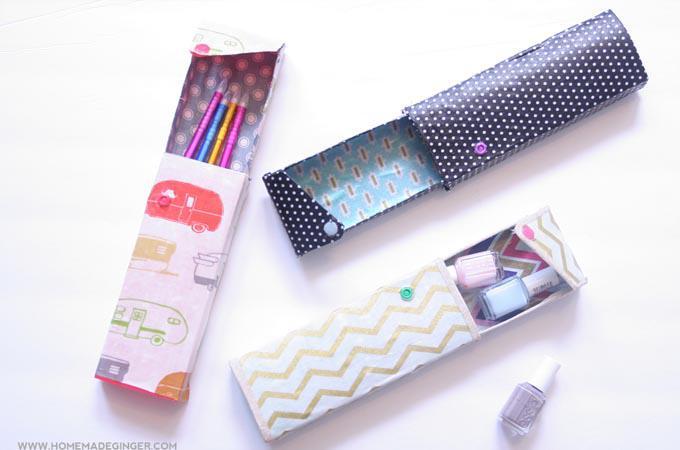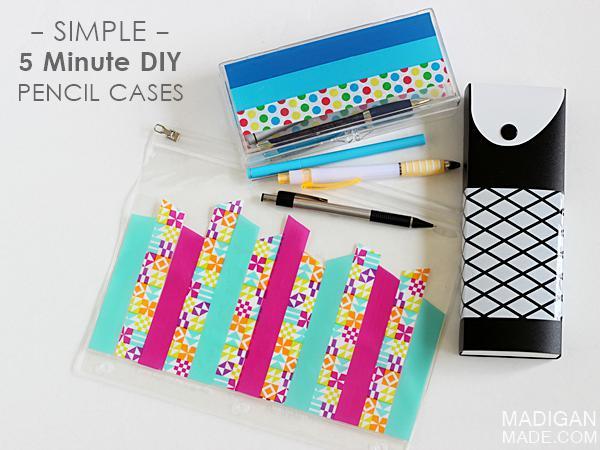The first image is the image on the left, the second image is the image on the right. Given the left and right images, does the statement "All the pencil cases feature animal-inspired shapes." hold true? Answer yes or no. No. 